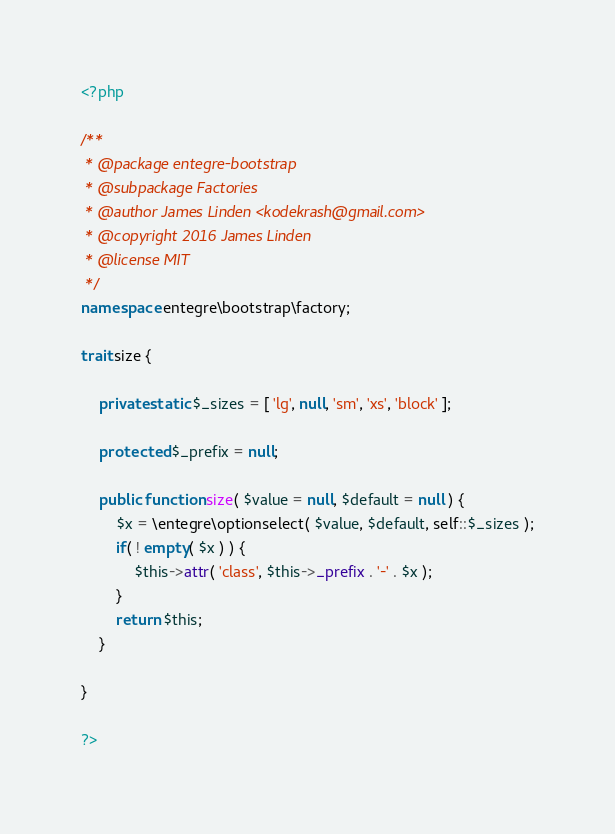Convert code to text. <code><loc_0><loc_0><loc_500><loc_500><_PHP_><?php

/**
 * @package entegre-bootstrap
 * @subpackage Factories
 * @author James Linden <kodekrash@gmail.com>
 * @copyright 2016 James Linden
 * @license MIT
 */
namespace entegre\bootstrap\factory;

trait size {

	private static $_sizes = [ 'lg', null, 'sm', 'xs', 'block' ];

	protected $_prefix = null;

	public function size( $value = null, $default = null ) {
		$x = \entegre\optionselect( $value, $default, self::$_sizes );
		if( ! empty( $x ) ) {
			$this->attr( 'class', $this->_prefix . '-' . $x );
		}
		return $this;
	}

}

?></code> 